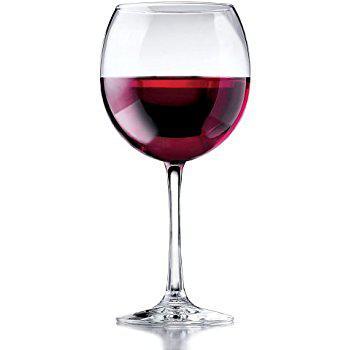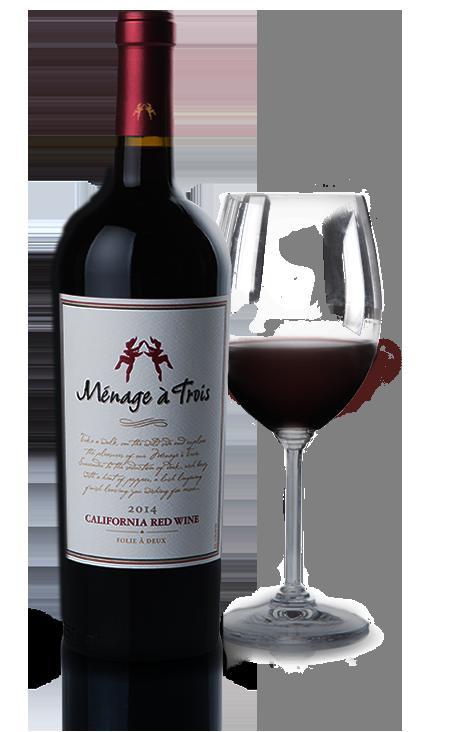The first image is the image on the left, the second image is the image on the right. For the images displayed, is the sentence "The left image features exactly two wine glasses." factually correct? Answer yes or no. No. 